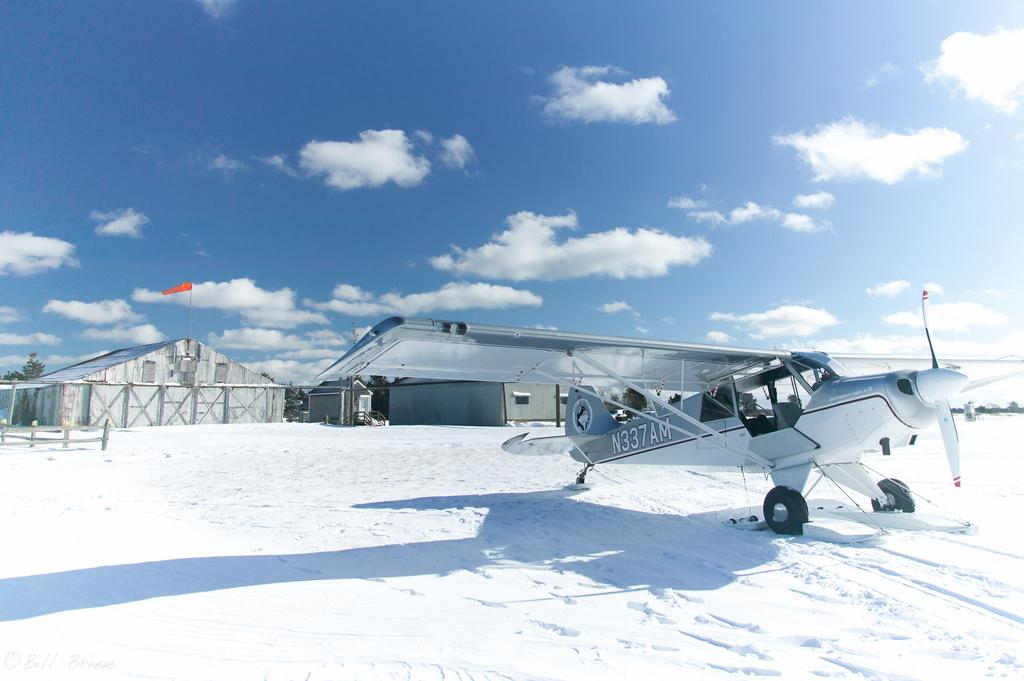<image>
Offer a succinct explanation of the picture presented. the back of a plane with N337AM on it 